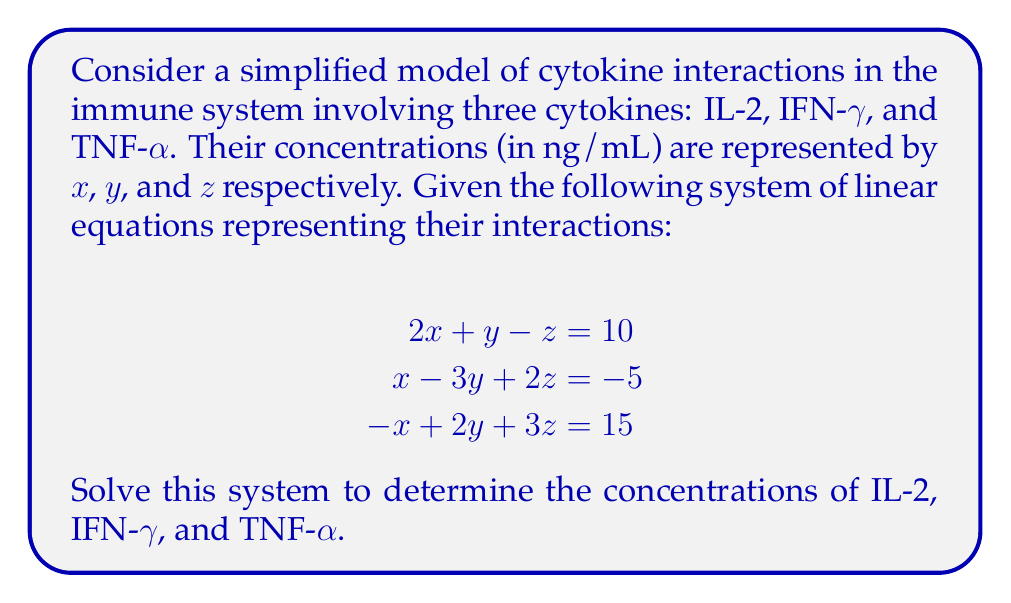Teach me how to tackle this problem. To solve this system of linear equations, we'll use the Gaussian elimination method:

1) First, write the augmented matrix:

   $$\begin{bmatrix}
   2 & 1 & -1 & | & 10 \\
   1 & -3 & 2 & | & -5 \\
   -1 & 2 & 3 & | & 15
   \end{bmatrix}$$

2) Multiply the first row by -1/2 and add it to the second row:

   $$\begin{bmatrix}
   2 & 1 & -1 & | & 10 \\
   0 & -3.5 & 2.5 & | & -10 \\
   -1 & 2 & 3 & | & 15
   \end{bmatrix}$$

3) Add the first row to the third row:

   $$\begin{bmatrix}
   2 & 1 & -1 & | & 10 \\
   0 & -3.5 & 2.5 & | & -10 \\
   0 & 3 & 2 & | & 25
   \end{bmatrix}$$

4) Multiply the second row by -6/7 and add it to the third row:

   $$\begin{bmatrix}
   2 & 1 & -1 & | & 10 \\
   0 & -3.5 & 2.5 & | & -10 \\
   0 & 0 & 3.714 & | & 17.143
   \end{bmatrix}$$

5) Now we have an upper triangular matrix. We can solve for $z$:

   $3.714z = 17.143$
   $z = 4.615$ ng/mL

6) Substitute this value into the second equation:

   $-3.5y + 2.5(4.615) = -10$
   $-3.5y = -21.538$
   $y = 6.154$ ng/mL

7) Finally, substitute these values into the first equation:

   $2x + 6.154 - 4.615 = 10$
   $2x = 8.461$
   $x = 4.231$ ng/mL

Therefore, the concentrations are:
IL-2 (x) = 4.231 ng/mL
IFN-γ (y) = 6.154 ng/mL
TNF-α (z) = 4.615 ng/mL
Answer: IL-2: 4.231 ng/mL
IFN-γ: 6.154 ng/mL
TNF-α: 4.615 ng/mL 